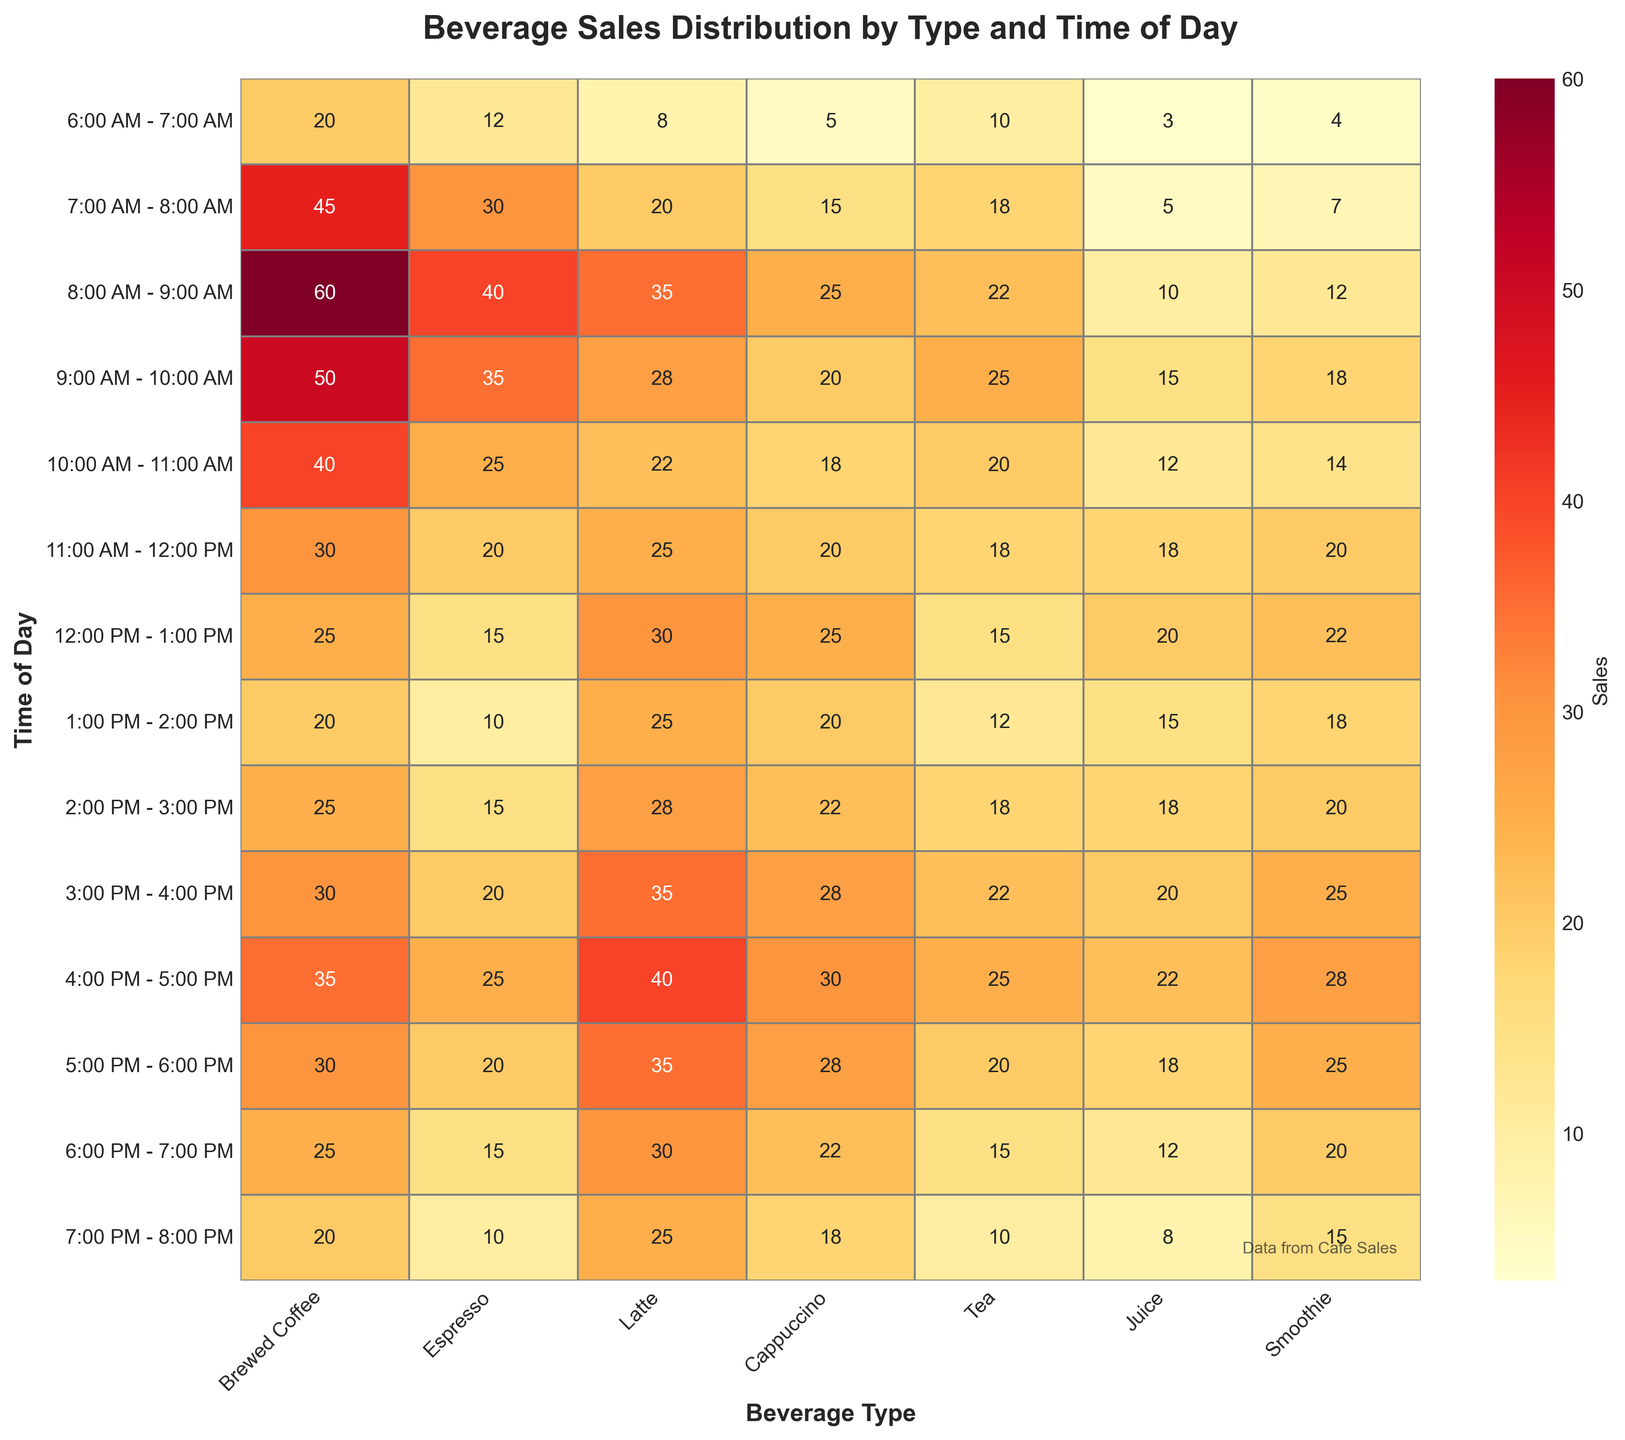What is the title of the heatmap? The title is usually prominently displayed at the top of the figure. In this case, it is indicated to be "Beverage Sales Distribution by Type and Time of Day" within the code description.
Answer: Beverage Sales Distribution by Type and Time of Day Which beverage shows the highest sales at 8:00 AM - 9:00 AM? To answer this, locate the row corresponding to 8:00 AM - 9:00 AM and identify the highest value in that row. The highest value is 60, under Brewed Coffee.
Answer: Brewed Coffee What time period shows the lowest sales for Juice? Locate the column for Juice and find the smallest value. The value 3 appears in the time period 6:00 AM - 7:00 AM.
Answer: 6:00 AM - 7:00 AM During which time period is the demand for Smoothies the highest? Look at the column for Smoothies and identify the highest value. The highest value is 28, which occurs at 4:00 PM - 5:00 PM.
Answer: 4:00 PM - 5:00 PM What is the average sale of Lattes between 8:00 AM and 10:00 AM? Find the values for Lattes in the time periods 8:00 AM - 9:00 AM and 9:00 AM - 10:00 AM, which are 35 and 28, respectively. The average is calculated as (35 + 28)/2.
Answer: 31.5 Which beverage has the most consistent sales throughout the day? Consistency can be judged by the smallest variation in sales numbers throughout the day. By examining the columns, Tea exhibits minimal variation in its numbers.
Answer: Tea How does the demand for brewed coffee at 4:00 PM - 5:00 PM compare to that at 6:00 AM - 7:00 AM? Identify the values for brewed coffee at 4:00 PM - 5:00 PM (35) and 6:00 AM - 7:00 AM (20). Comparing these shows the demand at 4:00 PM is higher.
Answer: Higher at 4:00 PM - 5:00 PM Which time of day shows the highest overall beverage sales? Sum the sales for each time period across all beverages. The time period with the highest sum is 8:00 AM - 9:00 AM (60+40+35+25+22+10+12 = 204).
Answer: 8:00 AM - 9:00 AM What is the total number of Cappuccino sales from 6:00 AM to 12:00 PM? Sum the values for Cappuccino from the time periods 6:00 AM - 12:00 PM (5 + 15 + 25 + 20 + 18 + 20) = 103.
Answer: 103 